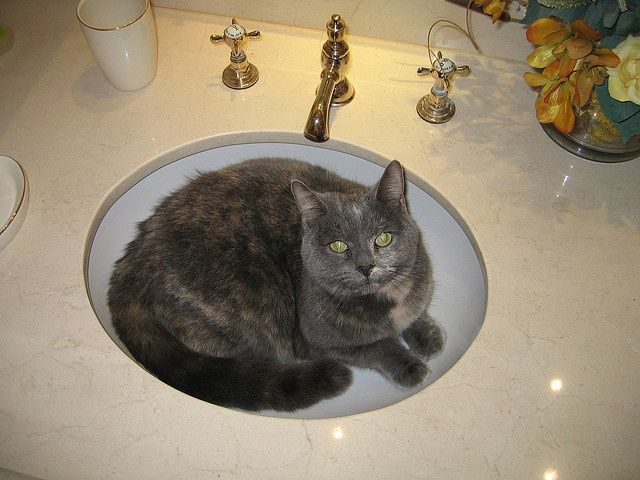Describe the objects in this image and their specific colors. I can see sink in black, gray, and darkgray tones, cat in black and gray tones, cup in black, tan, and gray tones, and vase in black, olive, and darkgreen tones in this image. 